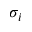Convert formula to latex. <formula><loc_0><loc_0><loc_500><loc_500>\sigma _ { i }</formula> 